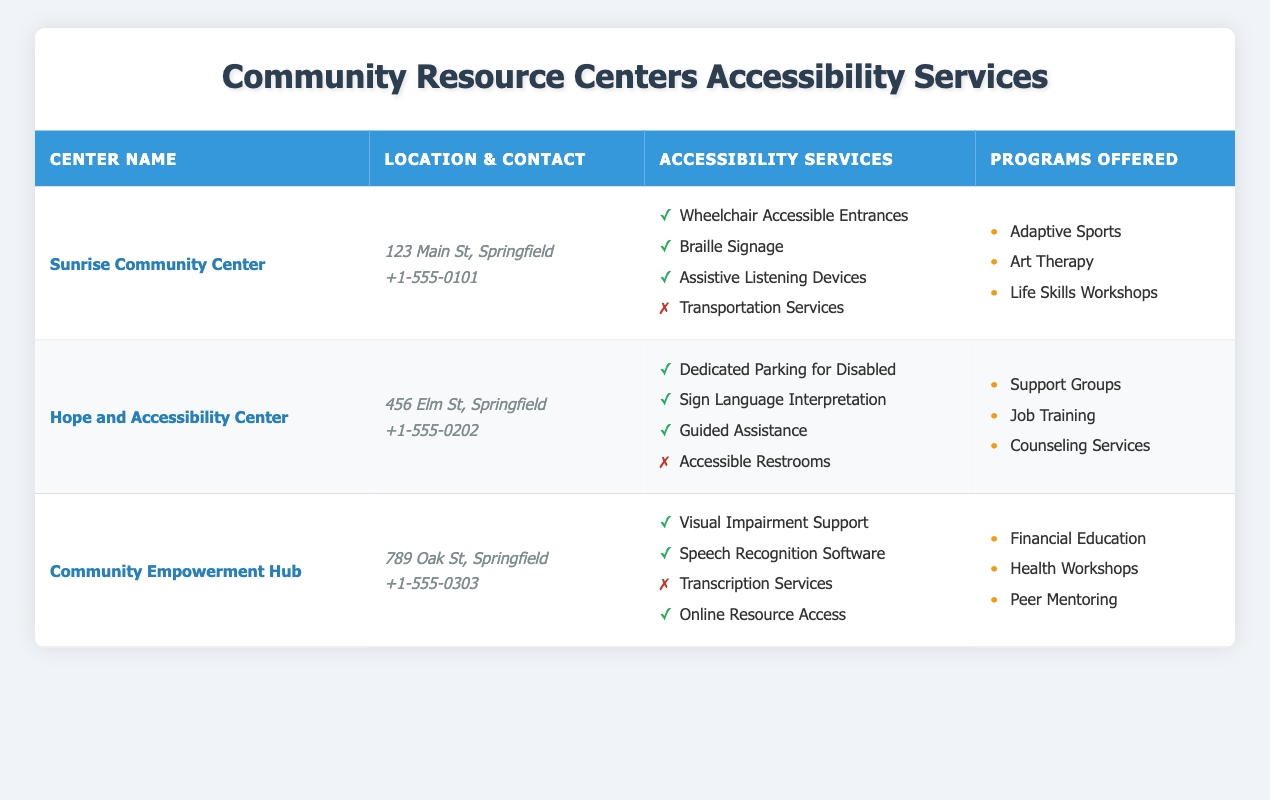What are the names of all the community resource centers listed? The table contains three resource centers: Sunrise Community Center, Hope and Accessibility Center, and Community Empowerment Hub.
Answer: Sunrise Community Center, Hope and Accessibility Center, Community Empowerment Hub Which center has a contact number ending in 0303? From the table, the Community Empowerment Hub has the contact number +1-555-0303, as seen in the contact section.
Answer: Community Empowerment Hub Does the Sunrise Community Center offer transportation services? The Sunrise Community Center lists Transportation Services as unavailable in its accessibility services, meaning it does not offer those services.
Answer: No How many centers offer assistive listening devices? Checking the accessibility services in the table, out of three centers, only the Sunrise Community Center offers Assistive Listening Devices, while the other two centers do not provide this service.
Answer: 1 Which center offers the most accessibility services? By reviewing the accessibility services provided by each center, the Sunrise Community Center offers three accessible services, while the Hope and Accessibility Center offers three, and the Community Empowerment Hub offers three as well. Thus all centers listed have the same count of accessible services.
Answer: All have three What percentage of the services offered by the Hope and Accessibility Center are available? The Hope and Accessibility Center has four accessibility services, with three available services. Thus, the percentage of available services is (3 available / 4 total) * 100 = 75%.
Answer: 75% Which program is offered at both the Sunrise Community Center and Hope and Accessibility Center? Analyzing the programs offered in both centers, the Sunrise Community Center has Adaptive Sports, Art Therapy, and Life Skills Workshops, while the Hope and Accessibility Center has Support Groups, Job Training, and Counseling Services. There are no overlapping programs between these two centers.
Answer: None If I need visual impairment support, which center should I go to? The Community Empowerment Hub lists Visual Impairment Support as an available service, making it the best choice for accessing this support.
Answer: Community Empowerment Hub Are there any centers with accessible restrooms? The Hope and Accessibility Center mentions accessible restrooms as unavailable in its accessibility services, meaning that none of the listed centers offer accessible restrooms.
Answer: No 